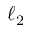<formula> <loc_0><loc_0><loc_500><loc_500>\ell _ { 2 }</formula> 